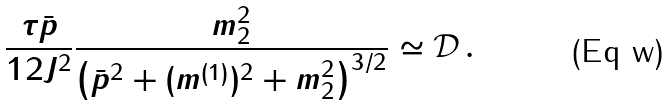Convert formula to latex. <formula><loc_0><loc_0><loc_500><loc_500>\frac { \tau \bar { p } } { 1 2 J ^ { 2 } } \frac { m _ { 2 } ^ { 2 } } { \left ( \bar { p } ^ { 2 } + ( m ^ { ( 1 ) } ) ^ { 2 } + m _ { 2 } ^ { 2 } \right ) ^ { 3 / 2 } } \simeq \mathcal { D } \, .</formula> 